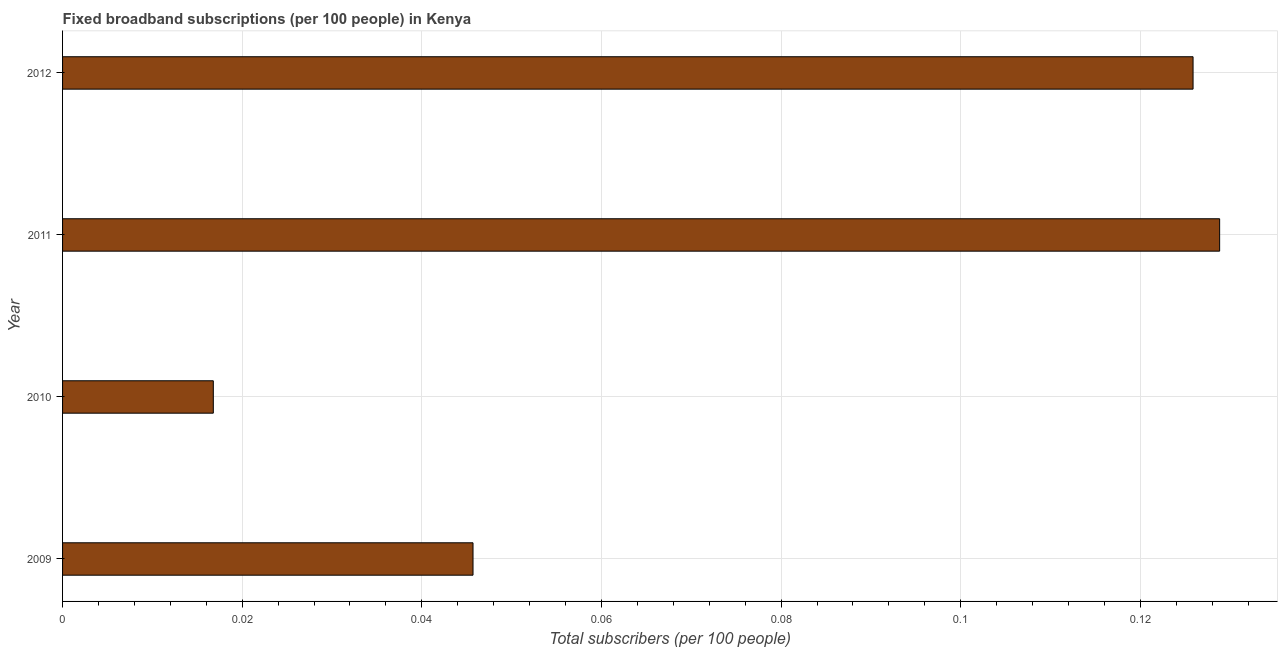Does the graph contain any zero values?
Make the answer very short. No. What is the title of the graph?
Keep it short and to the point. Fixed broadband subscriptions (per 100 people) in Kenya. What is the label or title of the X-axis?
Offer a very short reply. Total subscribers (per 100 people). What is the label or title of the Y-axis?
Your answer should be very brief. Year. What is the total number of fixed broadband subscriptions in 2010?
Offer a terse response. 0.02. Across all years, what is the maximum total number of fixed broadband subscriptions?
Give a very brief answer. 0.13. Across all years, what is the minimum total number of fixed broadband subscriptions?
Provide a succinct answer. 0.02. In which year was the total number of fixed broadband subscriptions maximum?
Make the answer very short. 2011. What is the sum of the total number of fixed broadband subscriptions?
Give a very brief answer. 0.32. What is the difference between the total number of fixed broadband subscriptions in 2009 and 2012?
Your response must be concise. -0.08. What is the average total number of fixed broadband subscriptions per year?
Offer a very short reply. 0.08. What is the median total number of fixed broadband subscriptions?
Provide a short and direct response. 0.09. In how many years, is the total number of fixed broadband subscriptions greater than 0.12 ?
Offer a very short reply. 2. What is the ratio of the total number of fixed broadband subscriptions in 2011 to that in 2012?
Offer a very short reply. 1.02. Is the total number of fixed broadband subscriptions in 2010 less than that in 2011?
Your answer should be compact. Yes. Is the difference between the total number of fixed broadband subscriptions in 2010 and 2012 greater than the difference between any two years?
Give a very brief answer. No. What is the difference between the highest and the second highest total number of fixed broadband subscriptions?
Ensure brevity in your answer.  0. What is the difference between the highest and the lowest total number of fixed broadband subscriptions?
Your answer should be very brief. 0.11. How many bars are there?
Keep it short and to the point. 4. Are all the bars in the graph horizontal?
Provide a short and direct response. Yes. What is the Total subscribers (per 100 people) of 2009?
Make the answer very short. 0.05. What is the Total subscribers (per 100 people) in 2010?
Give a very brief answer. 0.02. What is the Total subscribers (per 100 people) in 2011?
Offer a very short reply. 0.13. What is the Total subscribers (per 100 people) in 2012?
Ensure brevity in your answer.  0.13. What is the difference between the Total subscribers (per 100 people) in 2009 and 2010?
Offer a terse response. 0.03. What is the difference between the Total subscribers (per 100 people) in 2009 and 2011?
Your response must be concise. -0.08. What is the difference between the Total subscribers (per 100 people) in 2009 and 2012?
Keep it short and to the point. -0.08. What is the difference between the Total subscribers (per 100 people) in 2010 and 2011?
Ensure brevity in your answer.  -0.11. What is the difference between the Total subscribers (per 100 people) in 2010 and 2012?
Your answer should be very brief. -0.11. What is the difference between the Total subscribers (per 100 people) in 2011 and 2012?
Ensure brevity in your answer.  0. What is the ratio of the Total subscribers (per 100 people) in 2009 to that in 2010?
Ensure brevity in your answer.  2.72. What is the ratio of the Total subscribers (per 100 people) in 2009 to that in 2011?
Ensure brevity in your answer.  0.35. What is the ratio of the Total subscribers (per 100 people) in 2009 to that in 2012?
Offer a terse response. 0.36. What is the ratio of the Total subscribers (per 100 people) in 2010 to that in 2011?
Provide a short and direct response. 0.13. What is the ratio of the Total subscribers (per 100 people) in 2010 to that in 2012?
Keep it short and to the point. 0.13. 